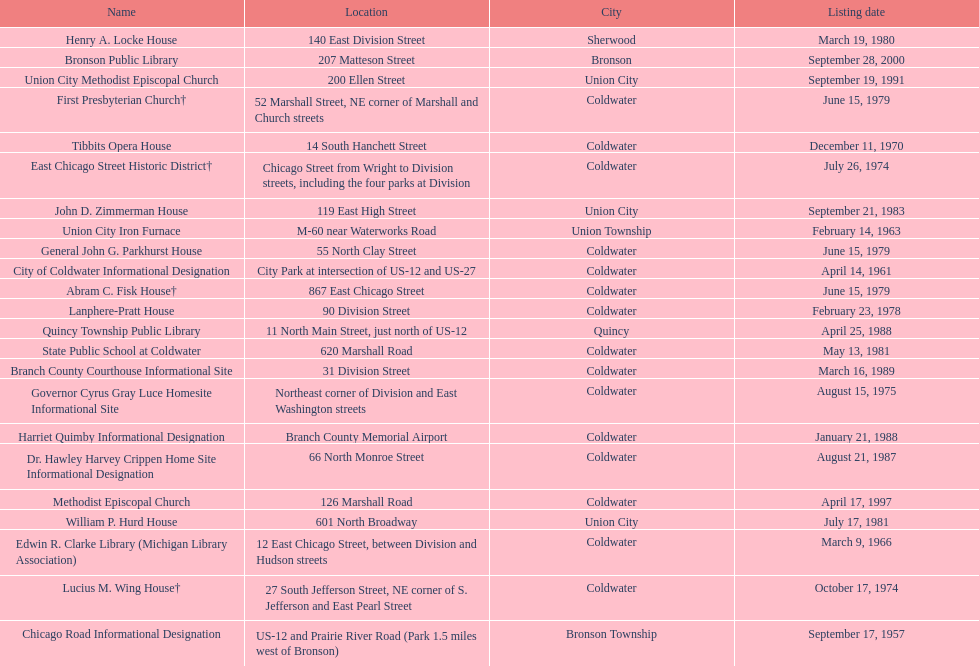How many years passed between the historic listing of public libraries in quincy and bronson? 12. Could you parse the entire table as a dict? {'header': ['Name', 'Location', 'City', 'Listing date'], 'rows': [['Henry A. Locke House', '140 East Division Street', 'Sherwood', 'March 19, 1980'], ['Bronson Public Library', '207 Matteson Street', 'Bronson', 'September 28, 2000'], ['Union City Methodist Episcopal Church', '200 Ellen Street', 'Union City', 'September 19, 1991'], ['First Presbyterian Church†', '52 Marshall Street, NE corner of Marshall and Church streets', 'Coldwater', 'June 15, 1979'], ['Tibbits Opera House', '14 South Hanchett Street', 'Coldwater', 'December 11, 1970'], ['East Chicago Street Historic District†', 'Chicago Street from Wright to Division streets, including the four parks at Division', 'Coldwater', 'July 26, 1974'], ['John D. Zimmerman House', '119 East High Street', 'Union City', 'September 21, 1983'], ['Union City Iron Furnace', 'M-60 near Waterworks Road', 'Union Township', 'February 14, 1963'], ['General John G. Parkhurst House', '55 North Clay Street', 'Coldwater', 'June 15, 1979'], ['City of Coldwater Informational Designation', 'City Park at intersection of US-12 and US-27', 'Coldwater', 'April 14, 1961'], ['Abram C. Fisk House†', '867 East Chicago Street', 'Coldwater', 'June 15, 1979'], ['Lanphere-Pratt House', '90 Division Street', 'Coldwater', 'February 23, 1978'], ['Quincy Township Public Library', '11 North Main Street, just north of US-12', 'Quincy', 'April 25, 1988'], ['State Public School at Coldwater', '620 Marshall Road', 'Coldwater', 'May 13, 1981'], ['Branch County Courthouse Informational Site', '31 Division Street', 'Coldwater', 'March 16, 1989'], ['Governor Cyrus Gray Luce Homesite Informational Site', 'Northeast corner of Division and East Washington streets', 'Coldwater', 'August 15, 1975'], ['Harriet Quimby Informational Designation', 'Branch County Memorial Airport', 'Coldwater', 'January 21, 1988'], ['Dr. Hawley Harvey Crippen Home Site Informational Designation', '66 North Monroe Street', 'Coldwater', 'August 21, 1987'], ['Methodist Episcopal Church', '126 Marshall Road', 'Coldwater', 'April 17, 1997'], ['William P. Hurd House', '601 North Broadway', 'Union City', 'July 17, 1981'], ['Edwin R. Clarke Library (Michigan Library Association)', '12 East Chicago Street, between Division and Hudson streets', 'Coldwater', 'March 9, 1966'], ['Lucius M. Wing House†', '27 South Jefferson Street, NE corner of S. Jefferson and East Pearl Street', 'Coldwater', 'October 17, 1974'], ['Chicago Road Informational Designation', 'US-12 and Prairie River Road (Park 1.5 miles west of Bronson)', 'Bronson Township', 'September 17, 1957']]} 